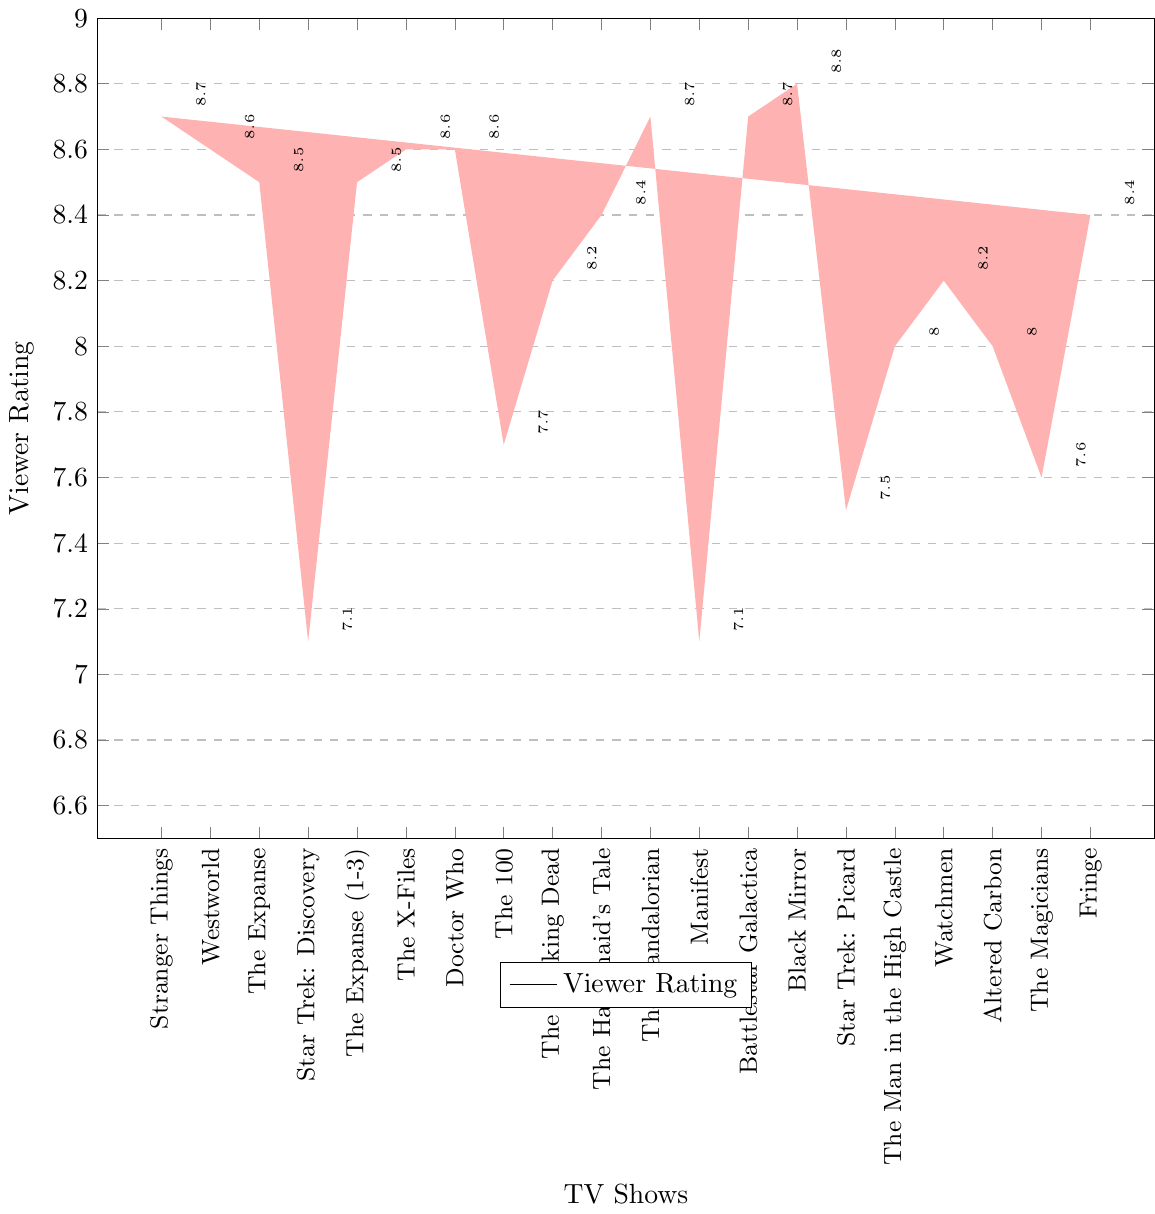What is the highest viewer rating among all the TV shows? To find the highest viewer rating, we look at the tallest bar, representing the highest value on the vertical axis (Viewer Rating). The highest rating shown is 8.8.
Answer: 8.8 Which TV show has the lowest viewer rating? To find the lowest viewer rating, we look at the shortest bar on the chart. The shortest bar corresponds to 'Star Trek: Discovery' and 'Manifest', with a rating of 7.1.
Answer: Star Trek: Discovery and Manifest What is the average viewer rating of Netflix shows? Locate all bars corresponding to Netflix shows: 'Stranger Things' (8.7), 'Black Mirror' (8.8), and 'Altered Carbon' (8.0). Sum these ratings: 8.7 + 8.8 + 8.0 = 25.5. Divide by the number of shows, 25.5 / 3 = 8.5.
Answer: 8.5 Which network has the most highly-rated show? Find the highest viewer rating and identify the network for this show. The highest rating is 8.8 (Black Mirror), which is on Netflix.
Answer: Netflix How many shows have a viewer rating above 8.5? Count all bars that extend above the 8.5 mark on the vertical axis. The shows are 'Stranger Things,' 'Black Mirror,' 'Westworld,' 'The Expanse,' 'The Mandalorian,' 'The Expanse (1-3),' 'Battlestar Galactica,' 'The X-Files,' and 'Doctor Who,' totaling 9 shows.
Answer: 9 Compare the viewer ratings of 'The Expanse' on Syfy and 'The Expanse' on Prime Video. Locate the bars for 'The Expanse' under Syfy and Prime Video. Both bars reach an 8.5 rating, so their ratings are equal.
Answer: Equal Which show has a higher viewer rating: 'The Handmaid’s Tale' or 'Fringe'? Find the bars for both 'The Handmaid’s Tale' and 'Fringe.' 'The Handmaid’s Tale' has a rating of 8.4, and 'Fringe' has the same rating of 8.4.
Answer: Equal What is the combined viewer rating of all CBS network shows? Locate the bars corresponding to CBS shows: 'Star Trek: Discovery' (7.1) and 'Star Trek: Picard' (7.5). Sum these ratings: 7.1 + 7.5 = 14.6.
Answer: 14.6 Which show from HBO has a higher viewer rating: 'Westworld' or 'Watchmen'? Locate the bars for 'Westworld' and 'Watchmen.' 'Westworld' has a rating of 8.6, while 'Watchmen' has a rating of 8.2. 'Westworld' is higher.
Answer: Westworld What is the difference in viewer rating between 'Doctor Who' and 'The Walking Dead'? Locate the bars for 'Doctor Who' and 'The Walking Dead.' The ratings are 8.6 and 8.2, respectively. Subtract the two ratings: 8.6 - 8.2 = 0.4.
Answer: 0.4 